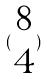<formula> <loc_0><loc_0><loc_500><loc_500>( \begin{matrix} 8 \\ 4 \end{matrix} )</formula> 